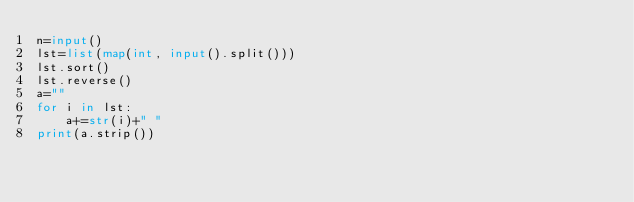Convert code to text. <code><loc_0><loc_0><loc_500><loc_500><_Python_>n=input()
lst=list(map(int, input().split()))
lst.sort()
lst.reverse()
a=""
for i in lst:
    a+=str(i)+" "
print(a.strip())</code> 